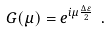Convert formula to latex. <formula><loc_0><loc_0><loc_500><loc_500>G ( \mu ) = e ^ { i \mu \frac { \Delta \varepsilon } { 2 } } \ .</formula> 